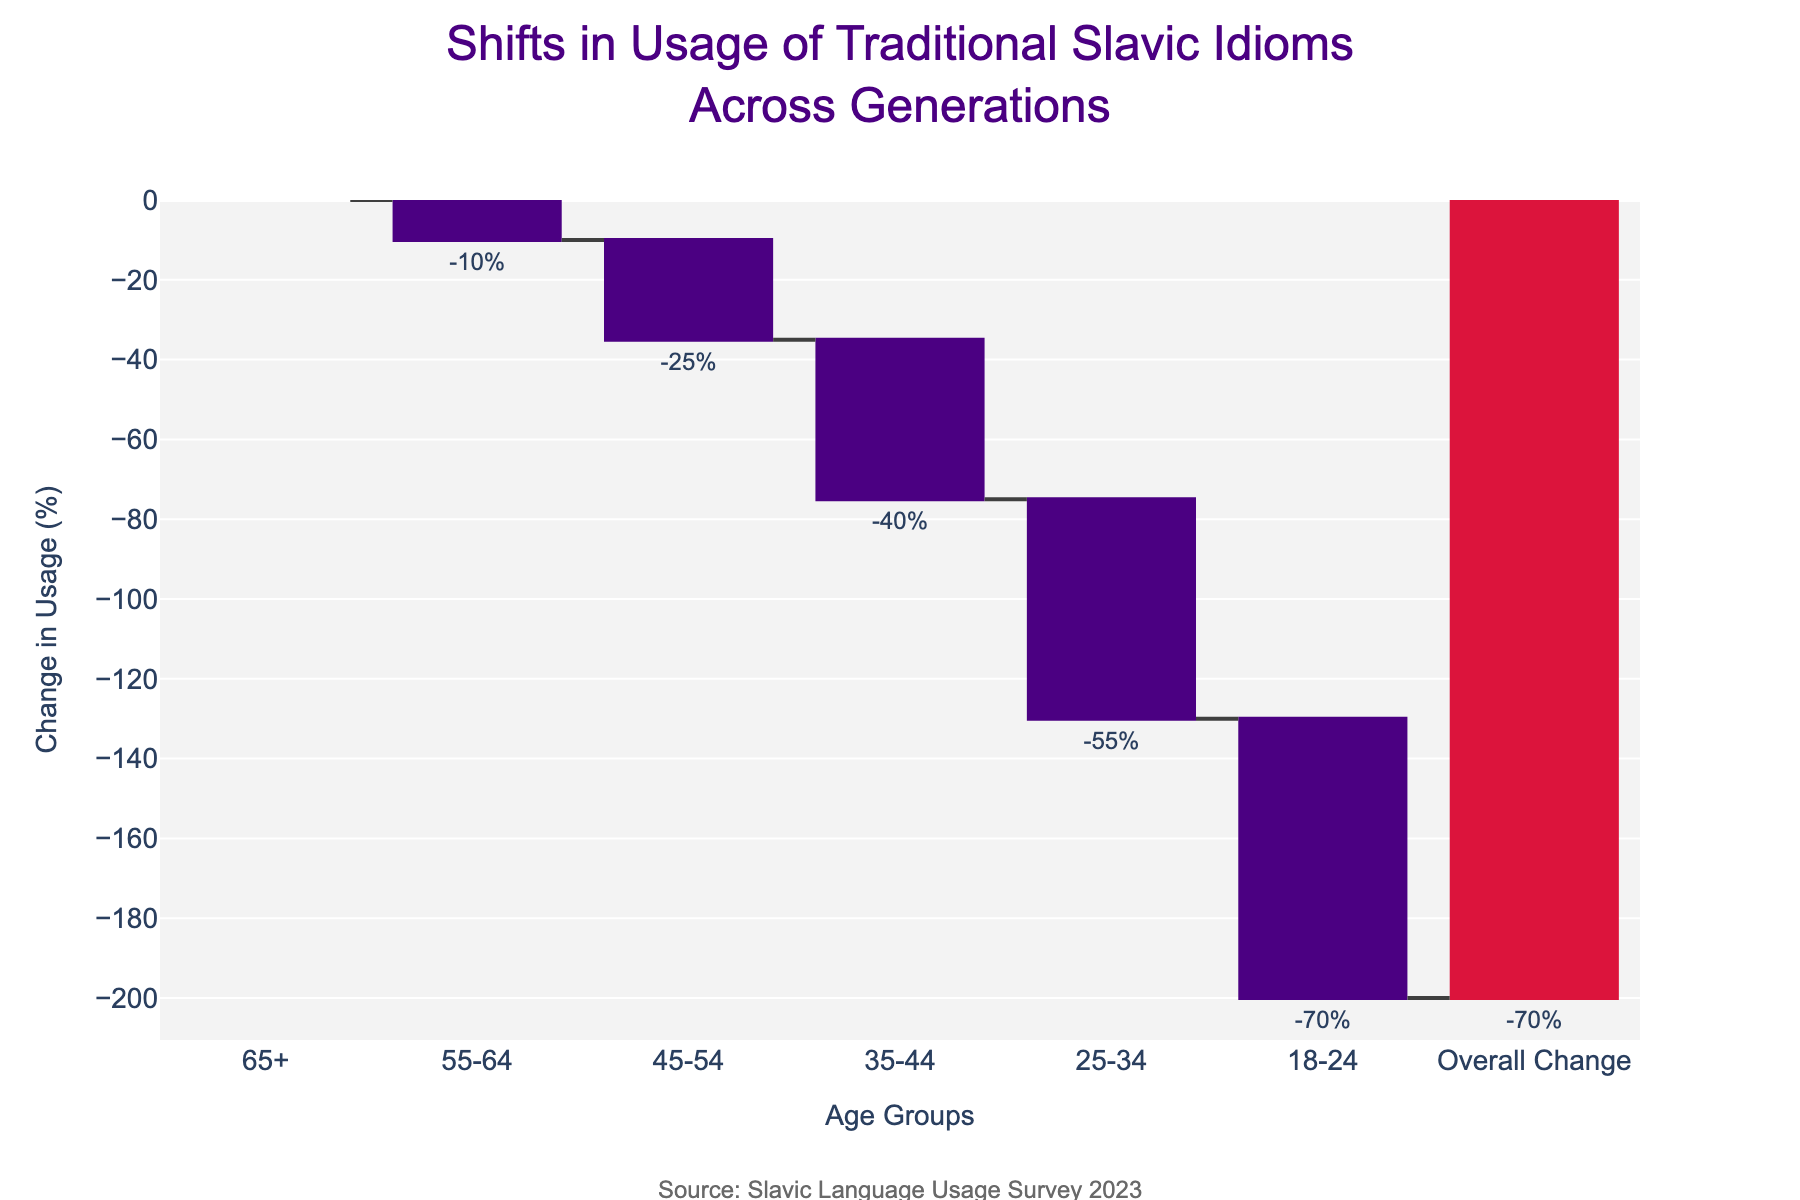what is the overall change in the usage of traditional Slavic idioms? The "Overall Change" bar in the chart itself indicates a 70% decrease in the usage of traditional Slavic idioms across all age groups.
Answer: -70% what color represents an increase in usage, and does any age group show such a trend? The color brown represents an increase in usage, but none of the age groups display an increase; they all show a decrease represented by the dark purple color.
Answer: No age group shows an increase Which age group has the largest drop in the usage of traditional Slavic idioms? The "18-24" age group shows the largest drop with a change of -70%.
Answer: 18-24 What is the combined percentage decrease for the 55-64 and 45-54 age groups? The 55-64 age group has a decrease of -10%, and the 45-54 age group has a decrease of -25%. Combining these results in a total decrease of -35%.
Answer: -35% How does the usage change for the 25-34 age group compare to the 65+ age group? The 25-34 age group shows a decrease of -55%, whereas the 65+ group remains unchanged at 0%. This means the 25-34 group had a significant decline while the 65+ group had no change.
Answer: 25-34 had a -55% change compared to 0% for 65+ How much more steeply did the 35-44 age group's usage decline compared to the 55-64 age group? The 35-44 age group has a decline of -40%, whereas the 55-64 group has a decline of -10%. Therefore, the 35-44 group's decline is -30% steeper.
Answer: -30% In the context of the Waterfall Chart, what does each bar represent? Each bar represents the percentage change in the usage of traditional Slavic idioms for a specific age group, with the final bar on the right representing the overall percentage change.
Answer: Percentage change for each age group How do the changes in usage compare between the 45-54 and 35-44 age groups? The 45-54 age group has a decrease of -25%, while the 35-44 age group shows a greater decrease of -40%.
Answer: 35-44 had a greater decrease Why is there a difference in color for the final bar labeled 'Overall Change'? The final bar uses a distinct color because it summarizes the total percentage change across all age groups, showing an overall decrease of -70%.
Answer: Different color represents 'Overall Change' 